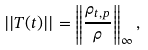<formula> <loc_0><loc_0><loc_500><loc_500>| | T ( t ) | | = \left \| \frac { \rho _ { t , p } } { \rho } \right \| _ { \infty } ,</formula> 